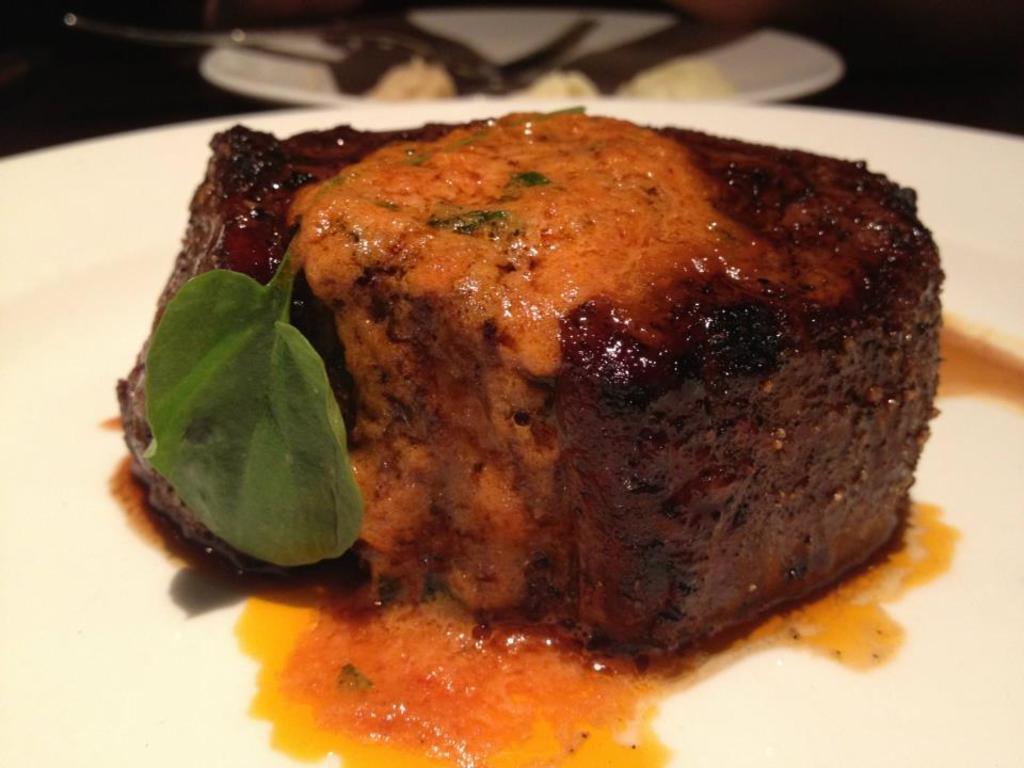In one or two sentences, can you explain what this image depicts? In this image I see a white plate on which there is food which is of brown and orange in color and I see a green leaf over here and it is dark in the background and I see another white plate over here on which there are few things. 